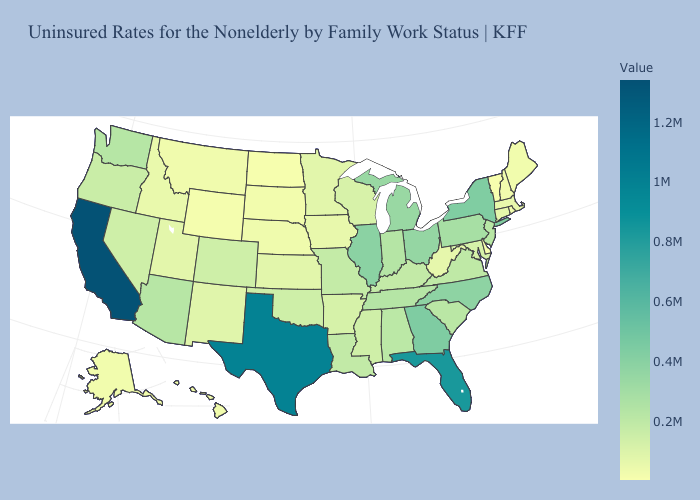Which states have the highest value in the USA?
Answer briefly. California. Among the states that border Iowa , does South Dakota have the lowest value?
Quick response, please. Yes. Among the states that border Illinois , does Kentucky have the highest value?
Concise answer only. No. Does Tennessee have a higher value than Georgia?
Answer briefly. No. Which states have the highest value in the USA?
Short answer required. California. Does New Hampshire have the lowest value in the USA?
Answer briefly. No. Does Wyoming have the lowest value in the West?
Be succinct. Yes. 